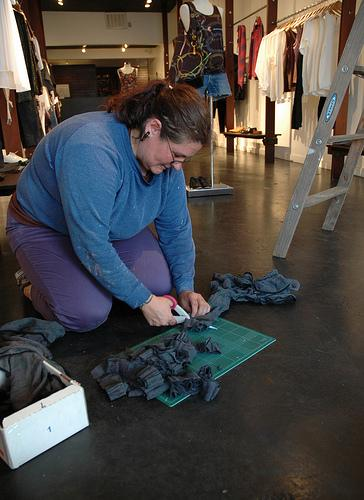Can you provide a description of the primary scenario taking place in this image? A woman wearing glasses and a blue shirt is cutting fabric with pink scissors while kneeling on a gray floor inside a clothing store. What type of material is the woman cutting and what are the scissors like? The woman is cutting blue material using white and pink scissors. What kind of flooring does the room have? The floor is colored gray. Can you list any additional objects or items that appear in the scene? White box on the floor, clothes on display, clothes hanging on a rack, shoes by the mannequin and pieces of fabric in a pile. State any noticeable body features or markings of the main subject. The woman has a tattoo on her wrist peeking from under her sleeve. Describe any accessories or attire the main subject in the image is wearing. The lady is wearing a blue shirt, blue pants, and glasses. Identify any furniture pieces in the scene. A wooden step ladder is present in the image. Tell me about the box on the floor with some numbers on it. The box has blue number one and seven prints on it. Mention an object on the wall and its color. There are lights on the wall with their color being white. What is the overall sentiment or vibe of the image? The image gives a vibe of a busy, creative, and dedicated individual working on a project in a clothing store. 